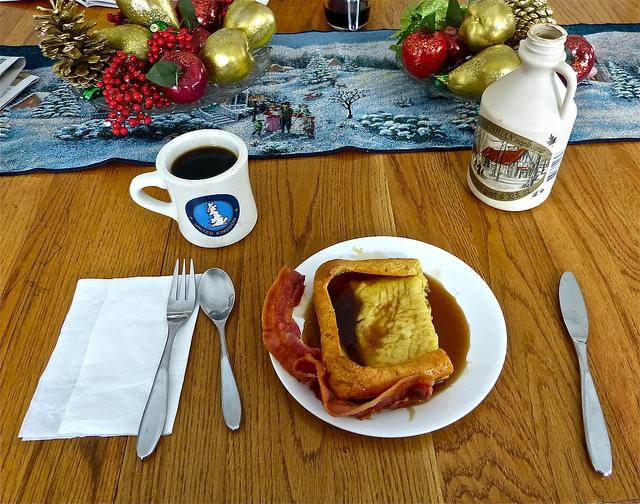In which season was this photo taken?
Be succinct. Winter. What food is shown?
Write a very short answer. Breakfast. Is the knife placed on the right?
Give a very brief answer. Yes. 